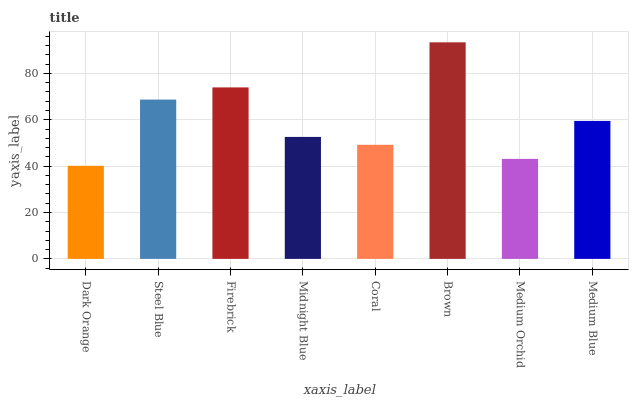Is Steel Blue the minimum?
Answer yes or no. No. Is Steel Blue the maximum?
Answer yes or no. No. Is Steel Blue greater than Dark Orange?
Answer yes or no. Yes. Is Dark Orange less than Steel Blue?
Answer yes or no. Yes. Is Dark Orange greater than Steel Blue?
Answer yes or no. No. Is Steel Blue less than Dark Orange?
Answer yes or no. No. Is Medium Blue the high median?
Answer yes or no. Yes. Is Midnight Blue the low median?
Answer yes or no. Yes. Is Dark Orange the high median?
Answer yes or no. No. Is Medium Blue the low median?
Answer yes or no. No. 